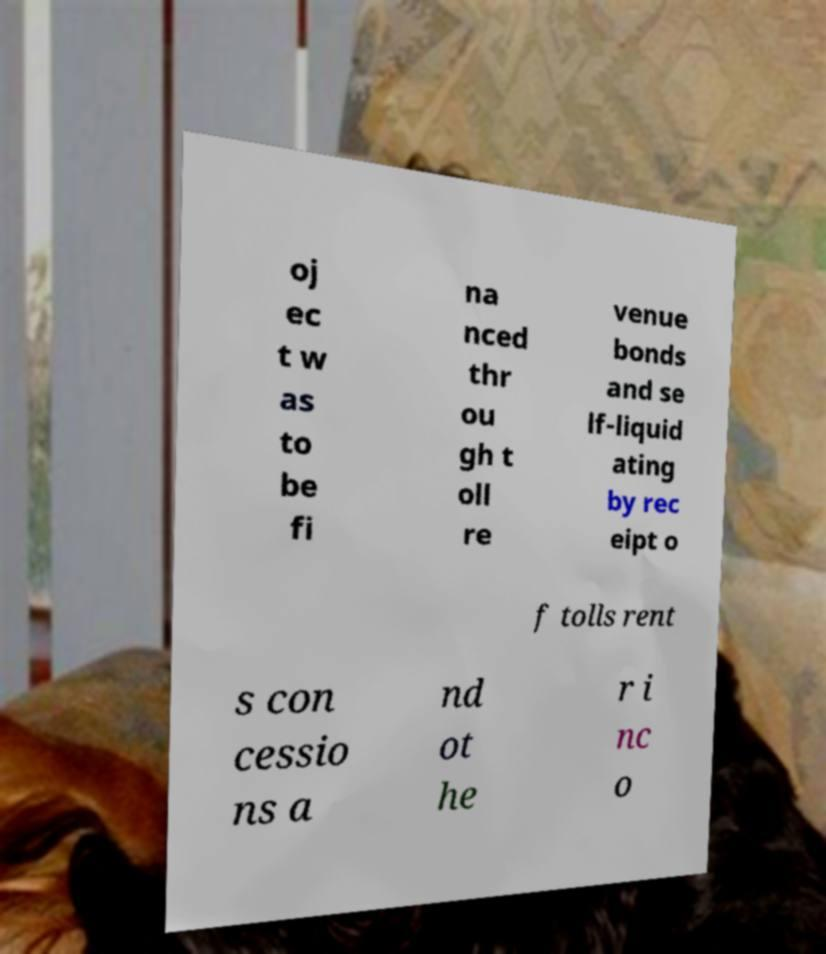Please read and relay the text visible in this image. What does it say? oj ec t w as to be fi na nced thr ou gh t oll re venue bonds and se lf-liquid ating by rec eipt o f tolls rent s con cessio ns a nd ot he r i nc o 